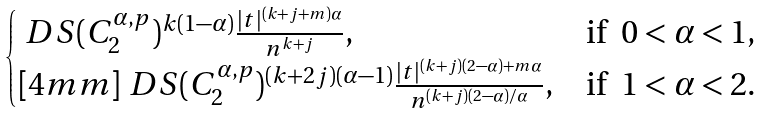<formula> <loc_0><loc_0><loc_500><loc_500>\begin{cases} \ D S ( C _ { 2 } ^ { \alpha , p } ) ^ { k ( 1 - \alpha ) } \frac { | t | ^ { ( k + j + m ) \alpha } } { n ^ { k + j } } , & \text {if \ $0 < \alpha < 1$,} \\ [ 4 m m ] \ D S ( C _ { 2 } ^ { \alpha , p } ) ^ { ( k + 2 j ) ( \alpha - 1 ) } \frac { | t | ^ { ( k + j ) ( 2 - \alpha ) + m \alpha } } { n ^ { ( k + j ) ( 2 - \alpha ) / \alpha } } , & \text {if \ $1 < \alpha < 2$.} \end{cases}</formula> 